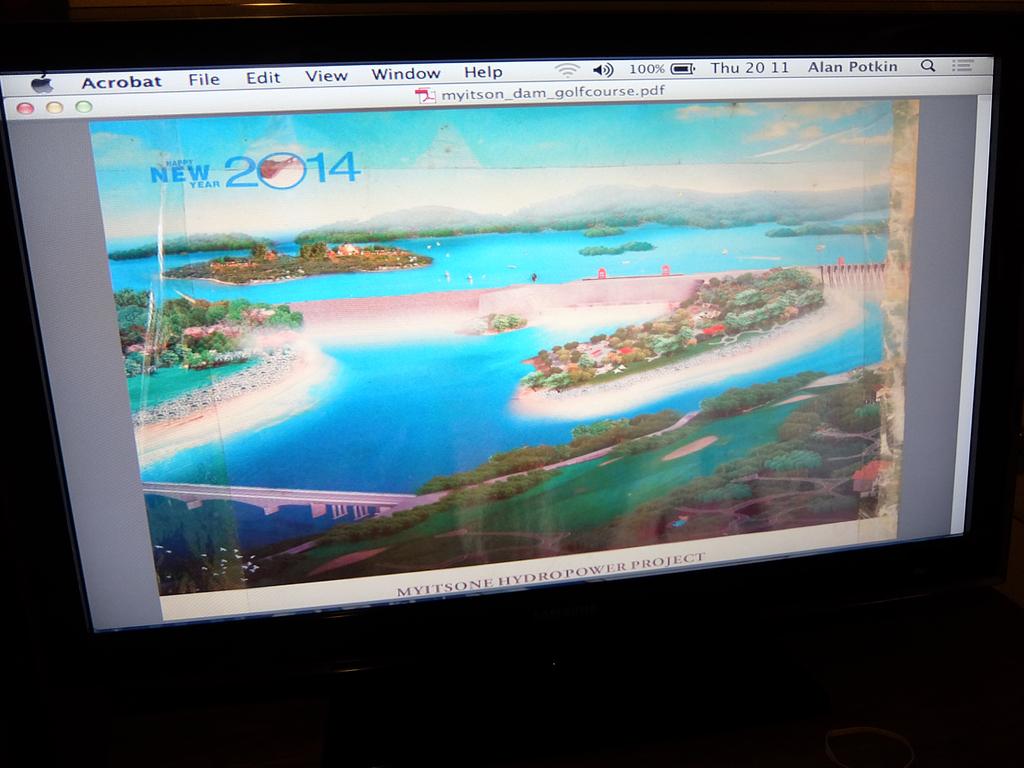What year is on the image?
Give a very brief answer. 2014. What day is it?
Ensure brevity in your answer.  Thursday. 